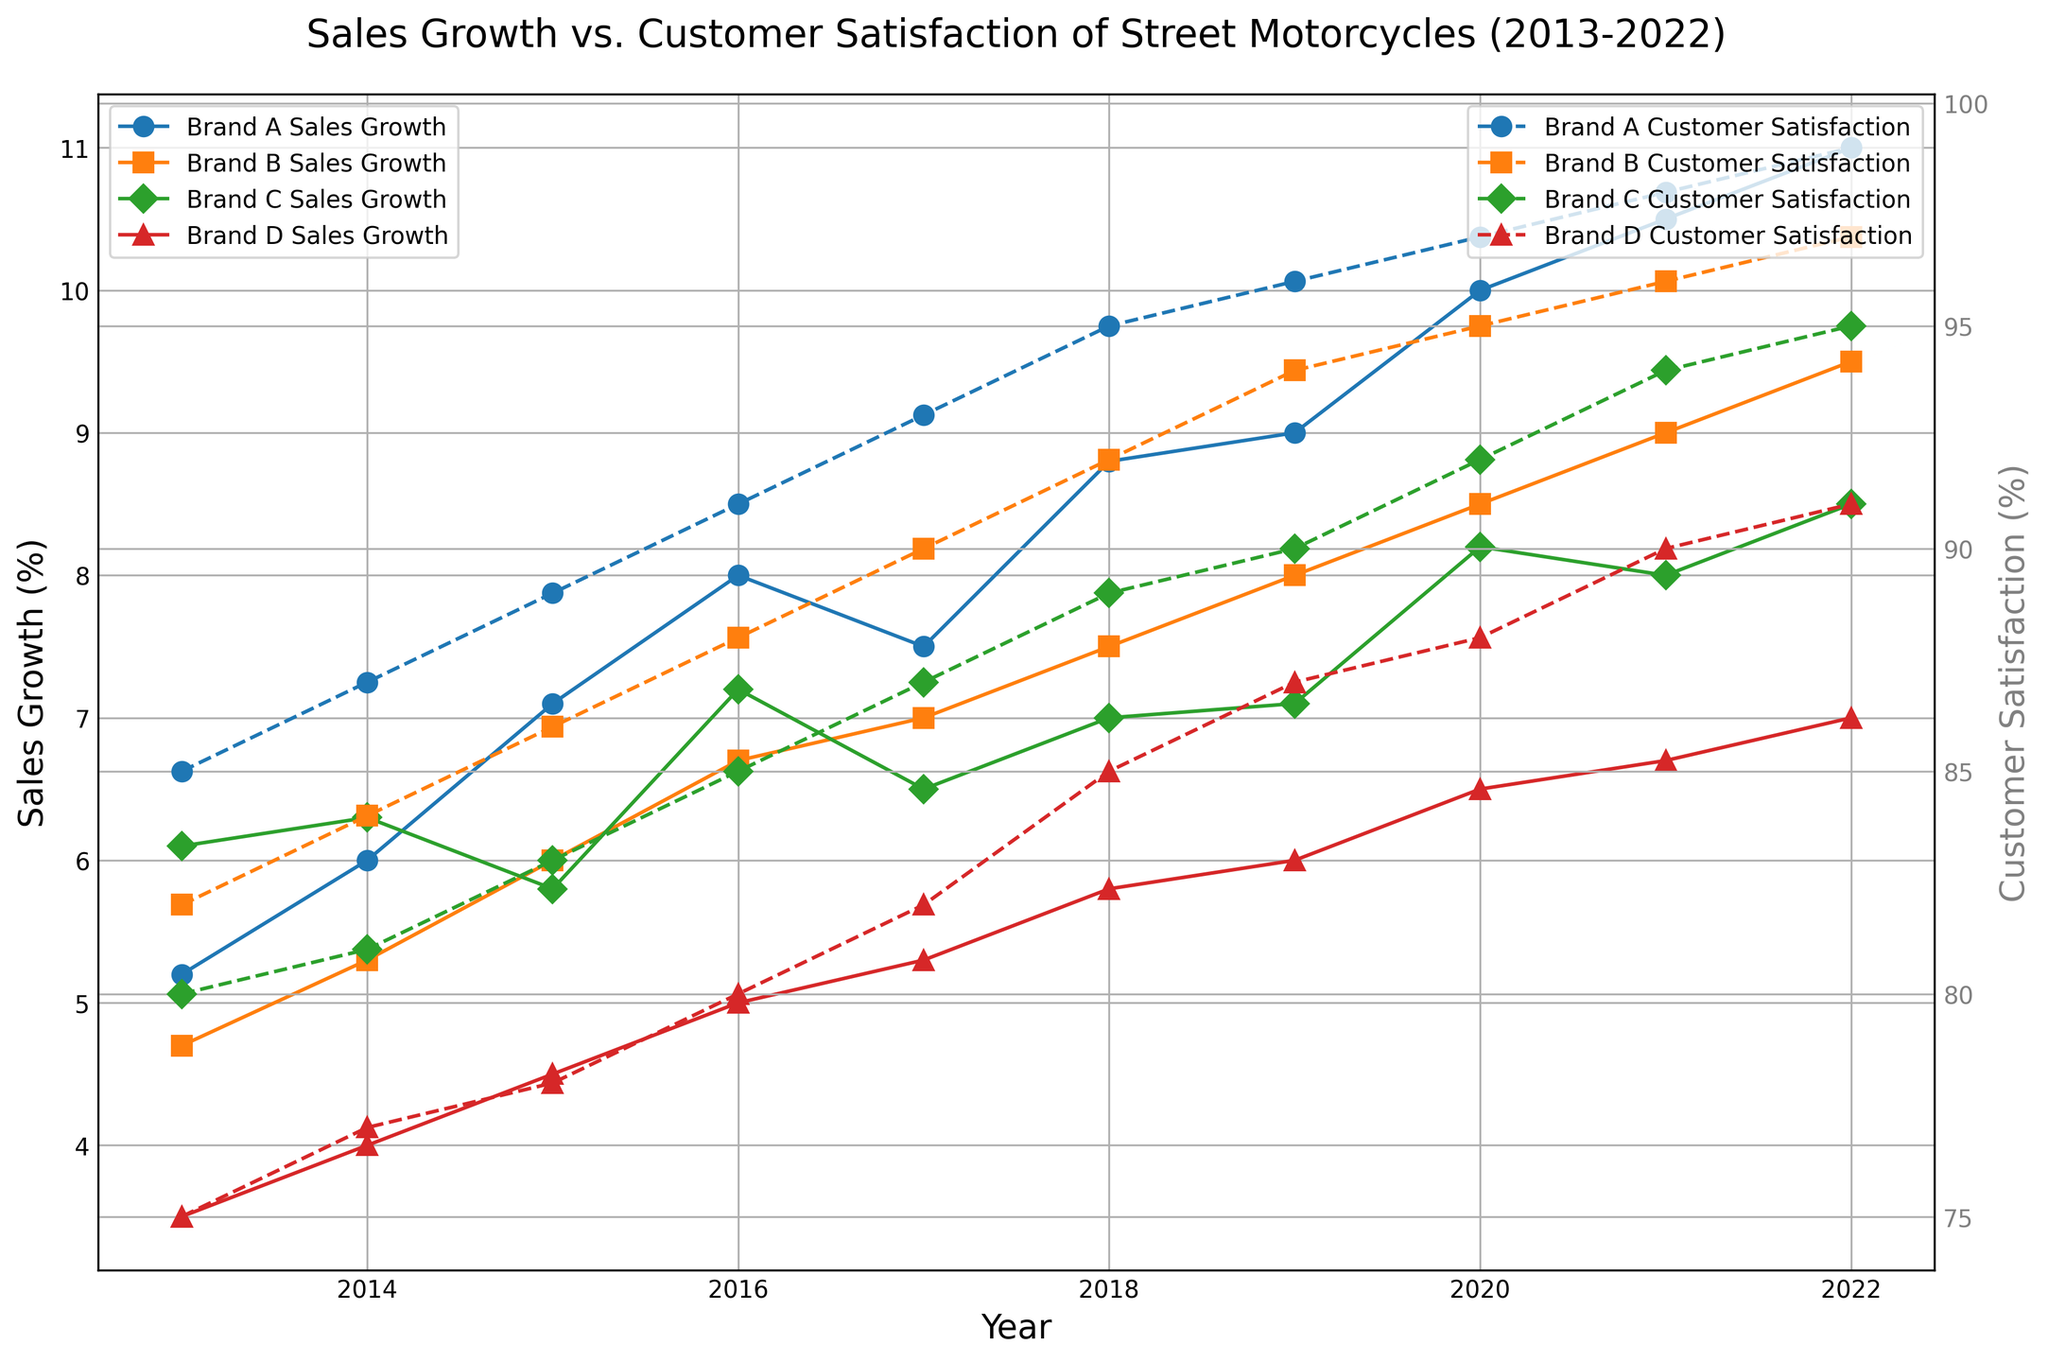What was the sales growth of Brand B in 2017? Find Brand B's data point for sales growth on the primary axis, which is in 2017. The corresponding value is marked with an orange solid line with a square marker.
Answer: 7.0% Which brand showed the highest customer satisfaction in 2015? Look at the secondary axis for 2015, and identify the highest peak in customer satisfaction values, which is marked with dashed lines for different colors. The grey dashed line, representing Brand A, has the highest peak.
Answer: Brand A How does the sales growth of Brand D in 2015 compare to 2016? Compare the point on the primary axis for Brand D in both 2015 and 2016. The sales growth increases from 4.5% in 2015 to 5.0% in 2016.
Answer: Increased Which brand had the lowest sales growth in 2020? Look at the primary axis for 2020 and identify the lowest point among the solid lines with different colors. The red solid line representing Brand D is the lowest.
Answer: Brand D Did Brand C's customer satisfaction ever surpass that of Brand A from 2013 to 2022? Look at the secondary axis over the period from 2013 to 2022 and compare the customer satisfaction values of Brand C and Brand A (green and blue dashed lines, respectively). Brand A always has higher or equal values.
Answer: No What is the average sales growth of Brand A from 2013 to 2015? Sum the sales growth percentages of Brand A for 2013, 2014, and 2015: (5.2 + 6.0 + 7.1) = 18.3, and divide by 3 for the average: 18.3/3 = 6.1.
Answer: 6.1% Which year did Brand C experience a drop in sales growth compared to the previous year? Observe the trend of the green solid line representing Brand C on the primary axis. The sales growth dropped from 8.0% in 2021 to 8.5% in 2022.
Answer: 2021-2022 What is the total increase in customer satisfaction for Brand B from 2013 to 2019? Calculate the difference in customer satisfaction for Brand B between 2019 and 2013: (94% - 82%) = 12.
Answer: 12% Does Brand D ever achieve a customer satisfaction rate above 90%? Refer to the secondary axis for Brand D's customer satisfaction (red dashed line) from 2013 to 2022. The highest value it reaches is 91% in 2022.
Answer: Yes What is the gap in customer satisfaction between Brand A and Brand D in 2022? Identify the customer satisfaction percentages for Brand A and Brand D in 2022 on the secondary axis: 99% for Brand A and 91% for Brand D. Subtract 91 from 99: 99 - 91 = 8.
Answer: 8 